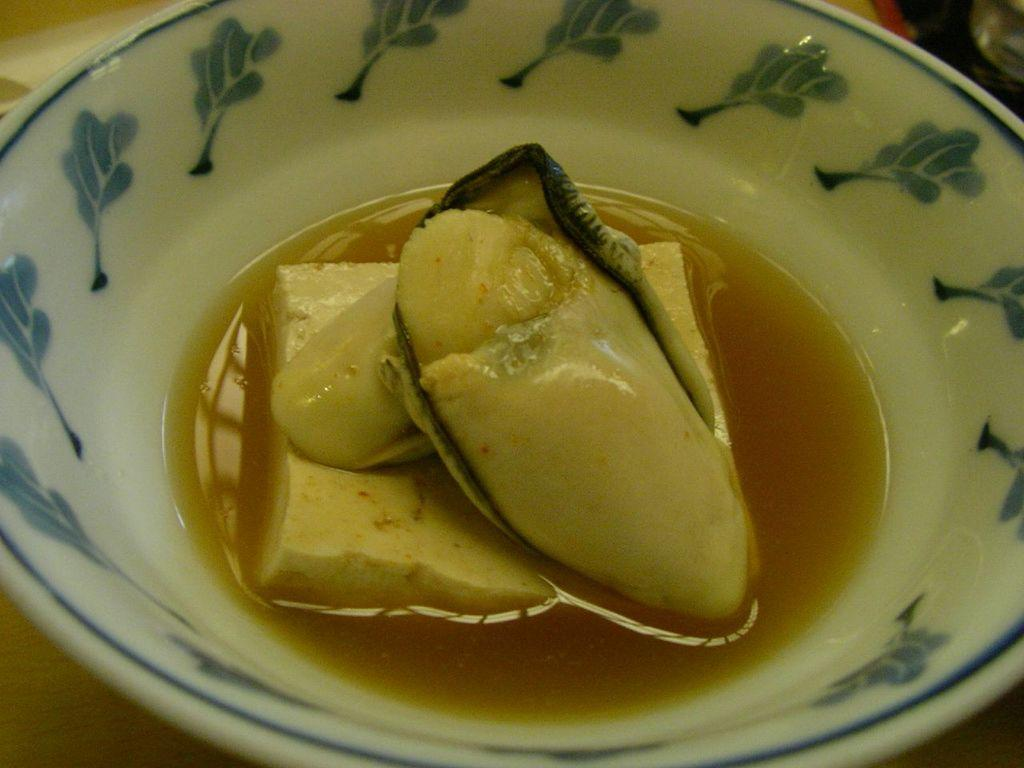What is in the bowl that is visible in the image? There is a food item in a bowl. What object is the bowl placed on? The bowl is placed on an object. What type of bread can be seen coming out of the gate in the image? There is no bread or gate present in the image. Can you see any steam rising from the food item in the image? The image does not show any steam rising from the food item. 